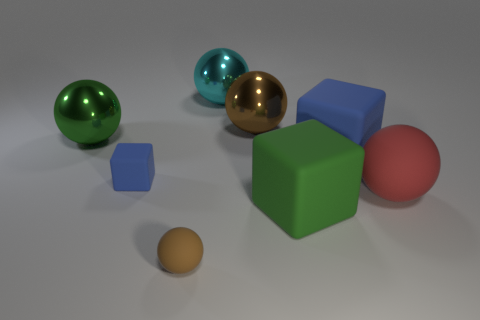What materials do the objects in the image appear to be made of? The objects in the image exhibit different appearances suggesting various materials. The spheres and the large cube give off reflective surfaces which could imply that they are made of polished metal or plastic with a metallic finish. The two smaller cubes appear to have a matte finish which might indicate they are made of a non-reflective material like wood or matte plastic. 